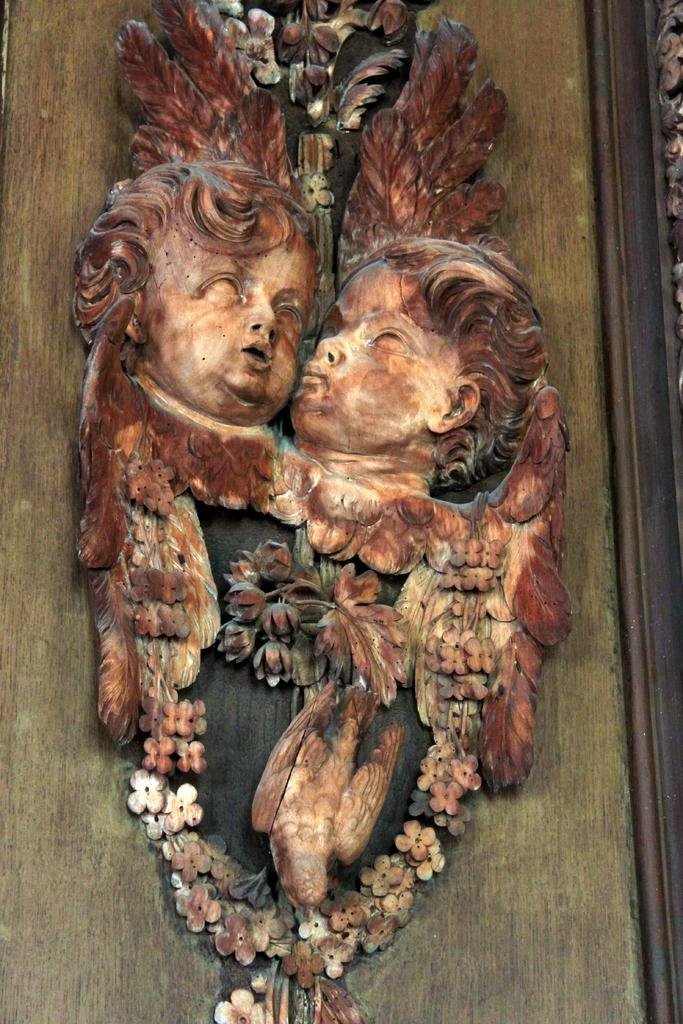What is the main subject of the image? There is a portrait in the center of the image. What elements are included in the portrait? The portrait contains flowers, two babies, and a bird. What type of train can be seen in the background of the portrait? There is no train present in the portrait or the image; it only contains flowers, two babies, and a bird. 